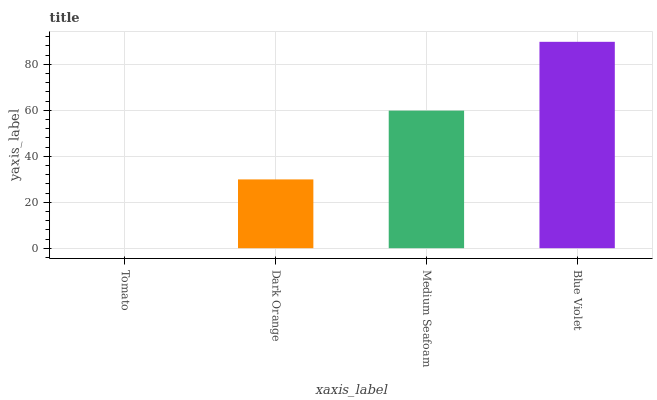Is Dark Orange the minimum?
Answer yes or no. No. Is Dark Orange the maximum?
Answer yes or no. No. Is Dark Orange greater than Tomato?
Answer yes or no. Yes. Is Tomato less than Dark Orange?
Answer yes or no. Yes. Is Tomato greater than Dark Orange?
Answer yes or no. No. Is Dark Orange less than Tomato?
Answer yes or no. No. Is Medium Seafoam the high median?
Answer yes or no. Yes. Is Dark Orange the low median?
Answer yes or no. Yes. Is Blue Violet the high median?
Answer yes or no. No. Is Medium Seafoam the low median?
Answer yes or no. No. 